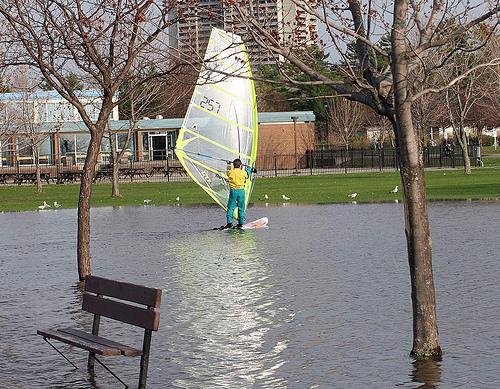Was there a flood?
Short answer required. Yes. Is that bench in the water?
Short answer required. Yes. Is the man going  very fast?
Keep it brief. No. 